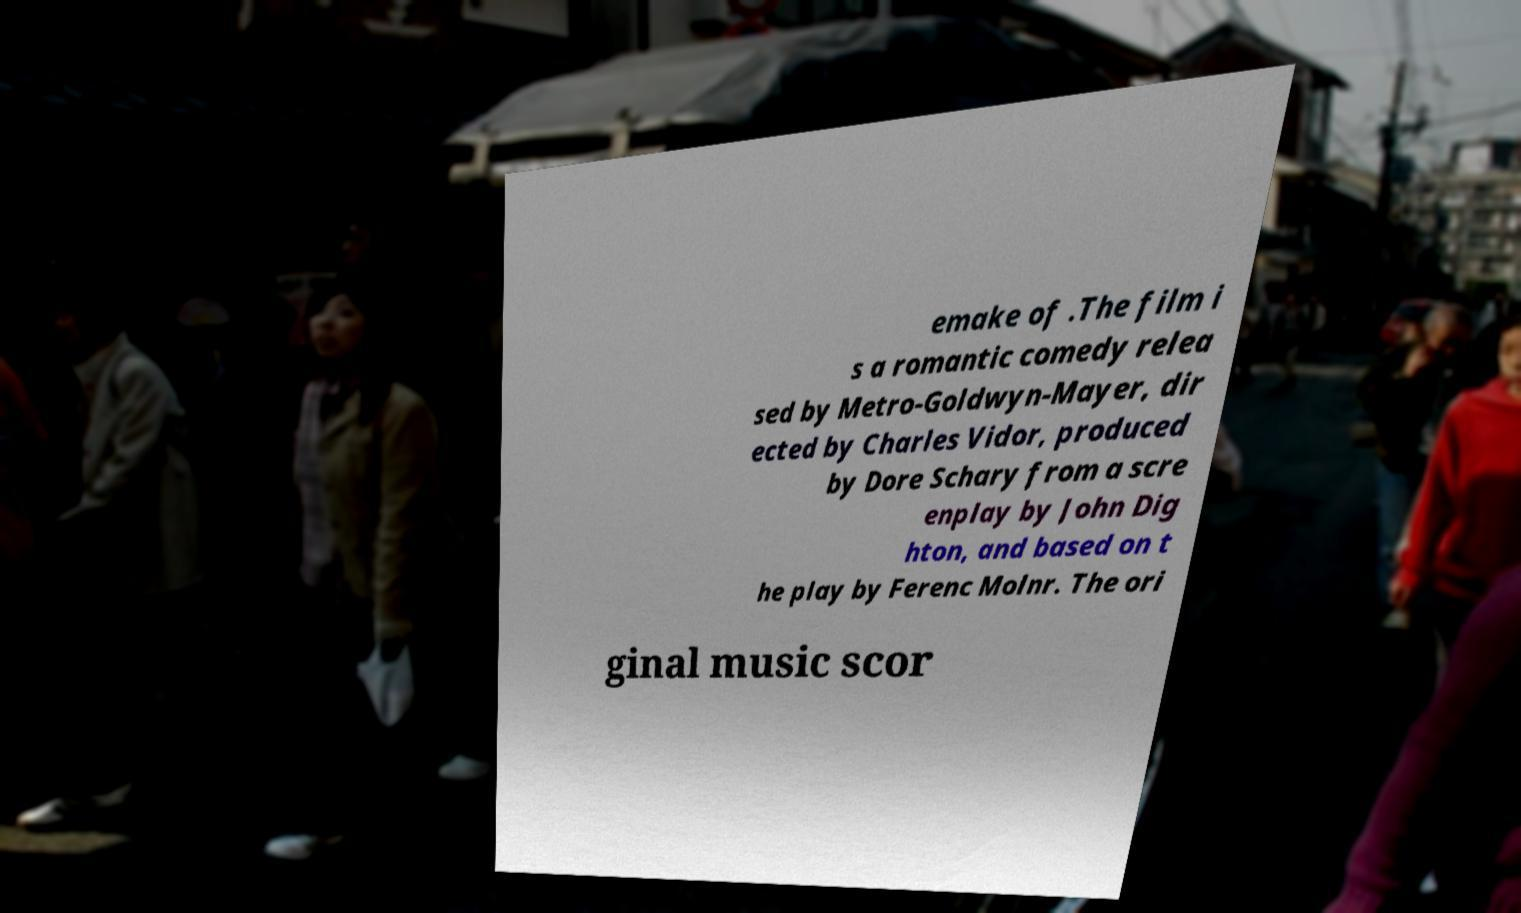What messages or text are displayed in this image? I need them in a readable, typed format. emake of .The film i s a romantic comedy relea sed by Metro-Goldwyn-Mayer, dir ected by Charles Vidor, produced by Dore Schary from a scre enplay by John Dig hton, and based on t he play by Ferenc Molnr. The ori ginal music scor 